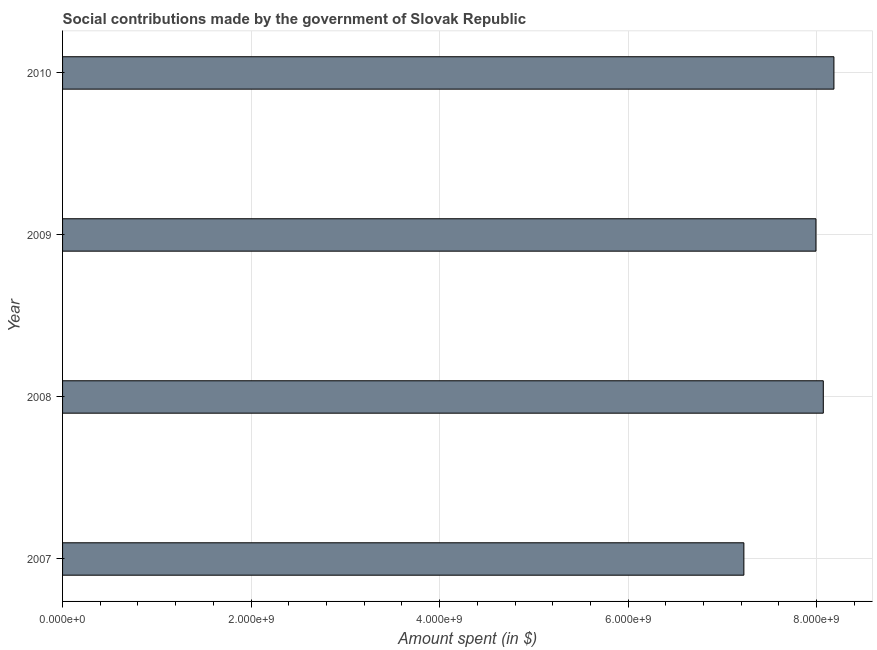Does the graph contain any zero values?
Provide a short and direct response. No. What is the title of the graph?
Offer a very short reply. Social contributions made by the government of Slovak Republic. What is the label or title of the X-axis?
Give a very brief answer. Amount spent (in $). What is the amount spent in making social contributions in 2008?
Make the answer very short. 8.07e+09. Across all years, what is the maximum amount spent in making social contributions?
Make the answer very short. 8.18e+09. Across all years, what is the minimum amount spent in making social contributions?
Offer a terse response. 7.23e+09. In which year was the amount spent in making social contributions maximum?
Give a very brief answer. 2010. What is the sum of the amount spent in making social contributions?
Provide a succinct answer. 3.15e+1. What is the difference between the amount spent in making social contributions in 2007 and 2010?
Offer a very short reply. -9.55e+08. What is the average amount spent in making social contributions per year?
Offer a very short reply. 7.87e+09. What is the median amount spent in making social contributions?
Your answer should be very brief. 8.03e+09. In how many years, is the amount spent in making social contributions greater than 2400000000 $?
Provide a short and direct response. 4. What is the ratio of the amount spent in making social contributions in 2007 to that in 2010?
Your answer should be very brief. 0.88. What is the difference between the highest and the second highest amount spent in making social contributions?
Make the answer very short. 1.13e+08. Is the sum of the amount spent in making social contributions in 2007 and 2009 greater than the maximum amount spent in making social contributions across all years?
Keep it short and to the point. Yes. What is the difference between the highest and the lowest amount spent in making social contributions?
Ensure brevity in your answer.  9.55e+08. In how many years, is the amount spent in making social contributions greater than the average amount spent in making social contributions taken over all years?
Give a very brief answer. 3. How many bars are there?
Your response must be concise. 4. Are all the bars in the graph horizontal?
Offer a terse response. Yes. How many years are there in the graph?
Provide a short and direct response. 4. What is the difference between two consecutive major ticks on the X-axis?
Keep it short and to the point. 2.00e+09. Are the values on the major ticks of X-axis written in scientific E-notation?
Make the answer very short. Yes. What is the Amount spent (in $) of 2007?
Offer a very short reply. 7.23e+09. What is the Amount spent (in $) of 2008?
Your answer should be very brief. 8.07e+09. What is the Amount spent (in $) of 2009?
Offer a very short reply. 7.99e+09. What is the Amount spent (in $) in 2010?
Your answer should be very brief. 8.18e+09. What is the difference between the Amount spent (in $) in 2007 and 2008?
Give a very brief answer. -8.43e+08. What is the difference between the Amount spent (in $) in 2007 and 2009?
Your answer should be very brief. -7.65e+08. What is the difference between the Amount spent (in $) in 2007 and 2010?
Ensure brevity in your answer.  -9.55e+08. What is the difference between the Amount spent (in $) in 2008 and 2009?
Keep it short and to the point. 7.78e+07. What is the difference between the Amount spent (in $) in 2008 and 2010?
Your response must be concise. -1.13e+08. What is the difference between the Amount spent (in $) in 2009 and 2010?
Your response must be concise. -1.91e+08. What is the ratio of the Amount spent (in $) in 2007 to that in 2008?
Your answer should be compact. 0.9. What is the ratio of the Amount spent (in $) in 2007 to that in 2009?
Your answer should be compact. 0.9. What is the ratio of the Amount spent (in $) in 2007 to that in 2010?
Keep it short and to the point. 0.88. What is the ratio of the Amount spent (in $) in 2009 to that in 2010?
Your answer should be compact. 0.98. 